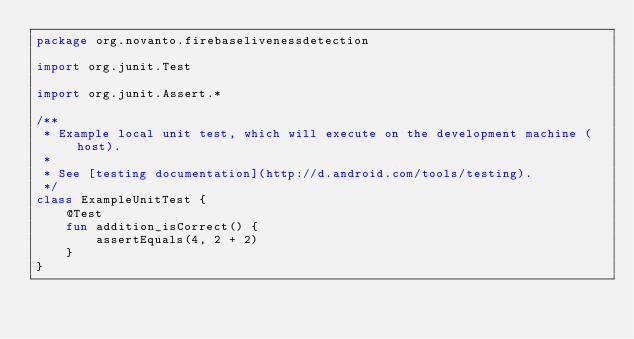Convert code to text. <code><loc_0><loc_0><loc_500><loc_500><_Kotlin_>package org.novanto.firebaselivenessdetection

import org.junit.Test

import org.junit.Assert.*

/**
 * Example local unit test, which will execute on the development machine (host).
 *
 * See [testing documentation](http://d.android.com/tools/testing).
 */
class ExampleUnitTest {
    @Test
    fun addition_isCorrect() {
        assertEquals(4, 2 + 2)
    }
}
</code> 